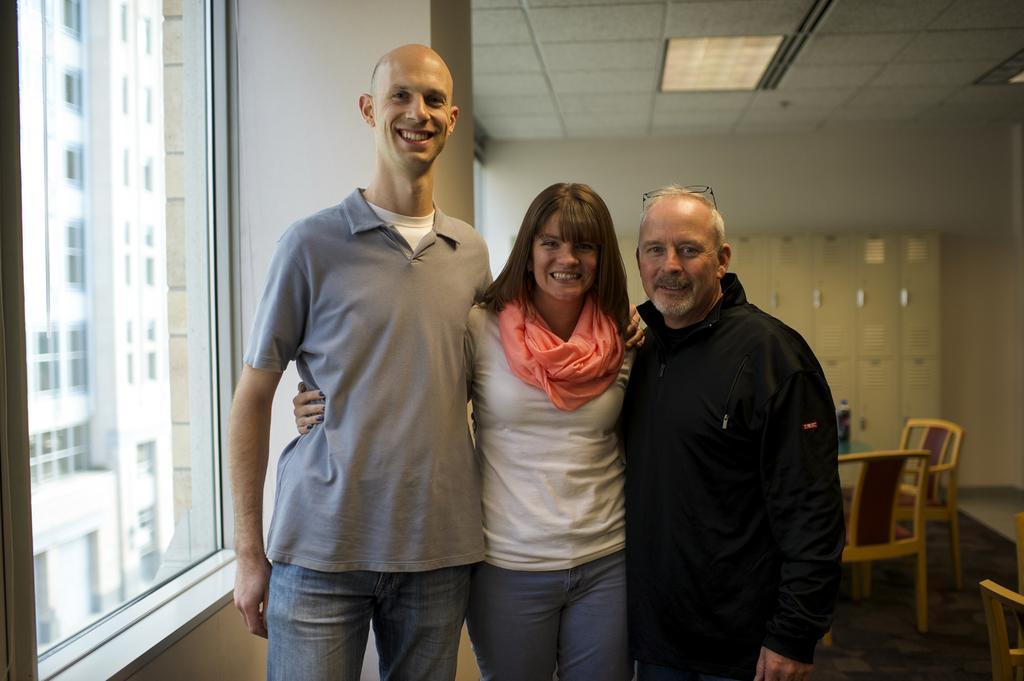Describe this image in one or two sentences. In this picture we can see two men and a woman standing and smiling, on the left side there is a glass, from the glass we can see a building, on the right side we can see chairs, there is the ceiling at the top of the picture. 